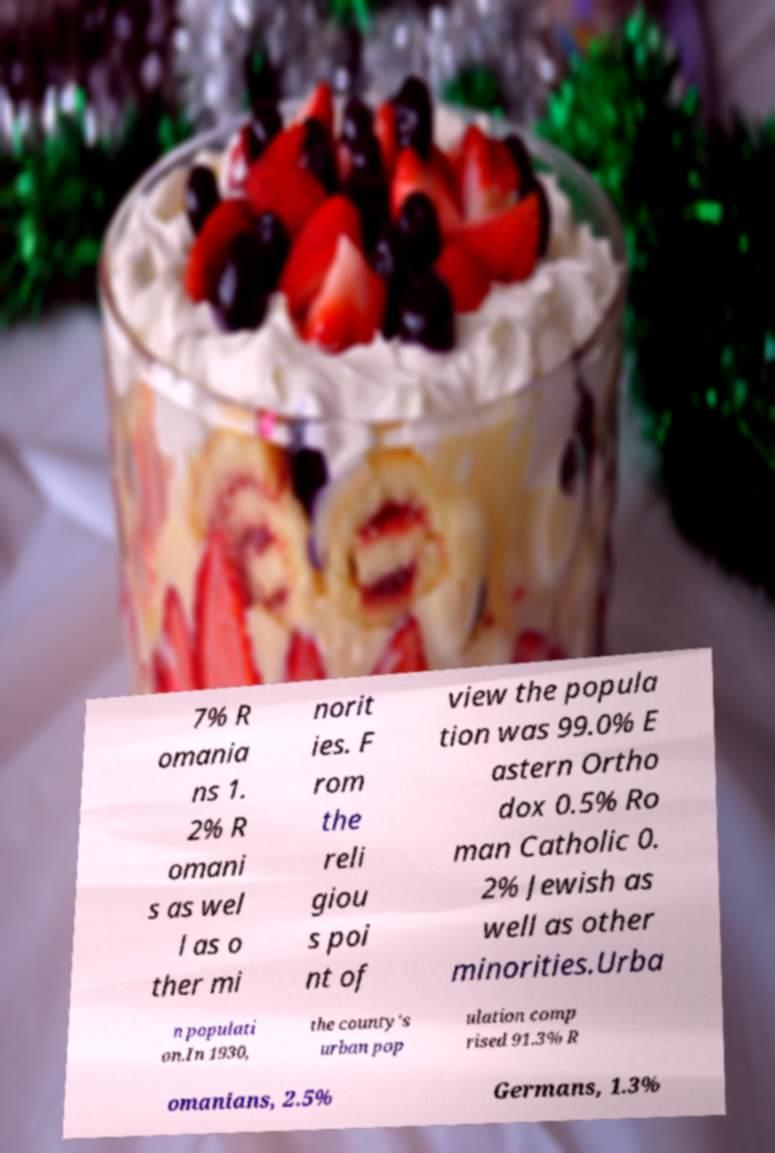Could you assist in decoding the text presented in this image and type it out clearly? 7% R omania ns 1. 2% R omani s as wel l as o ther mi norit ies. F rom the reli giou s poi nt of view the popula tion was 99.0% E astern Ortho dox 0.5% Ro man Catholic 0. 2% Jewish as well as other minorities.Urba n populati on.In 1930, the county's urban pop ulation comp rised 91.3% R omanians, 2.5% Germans, 1.3% 